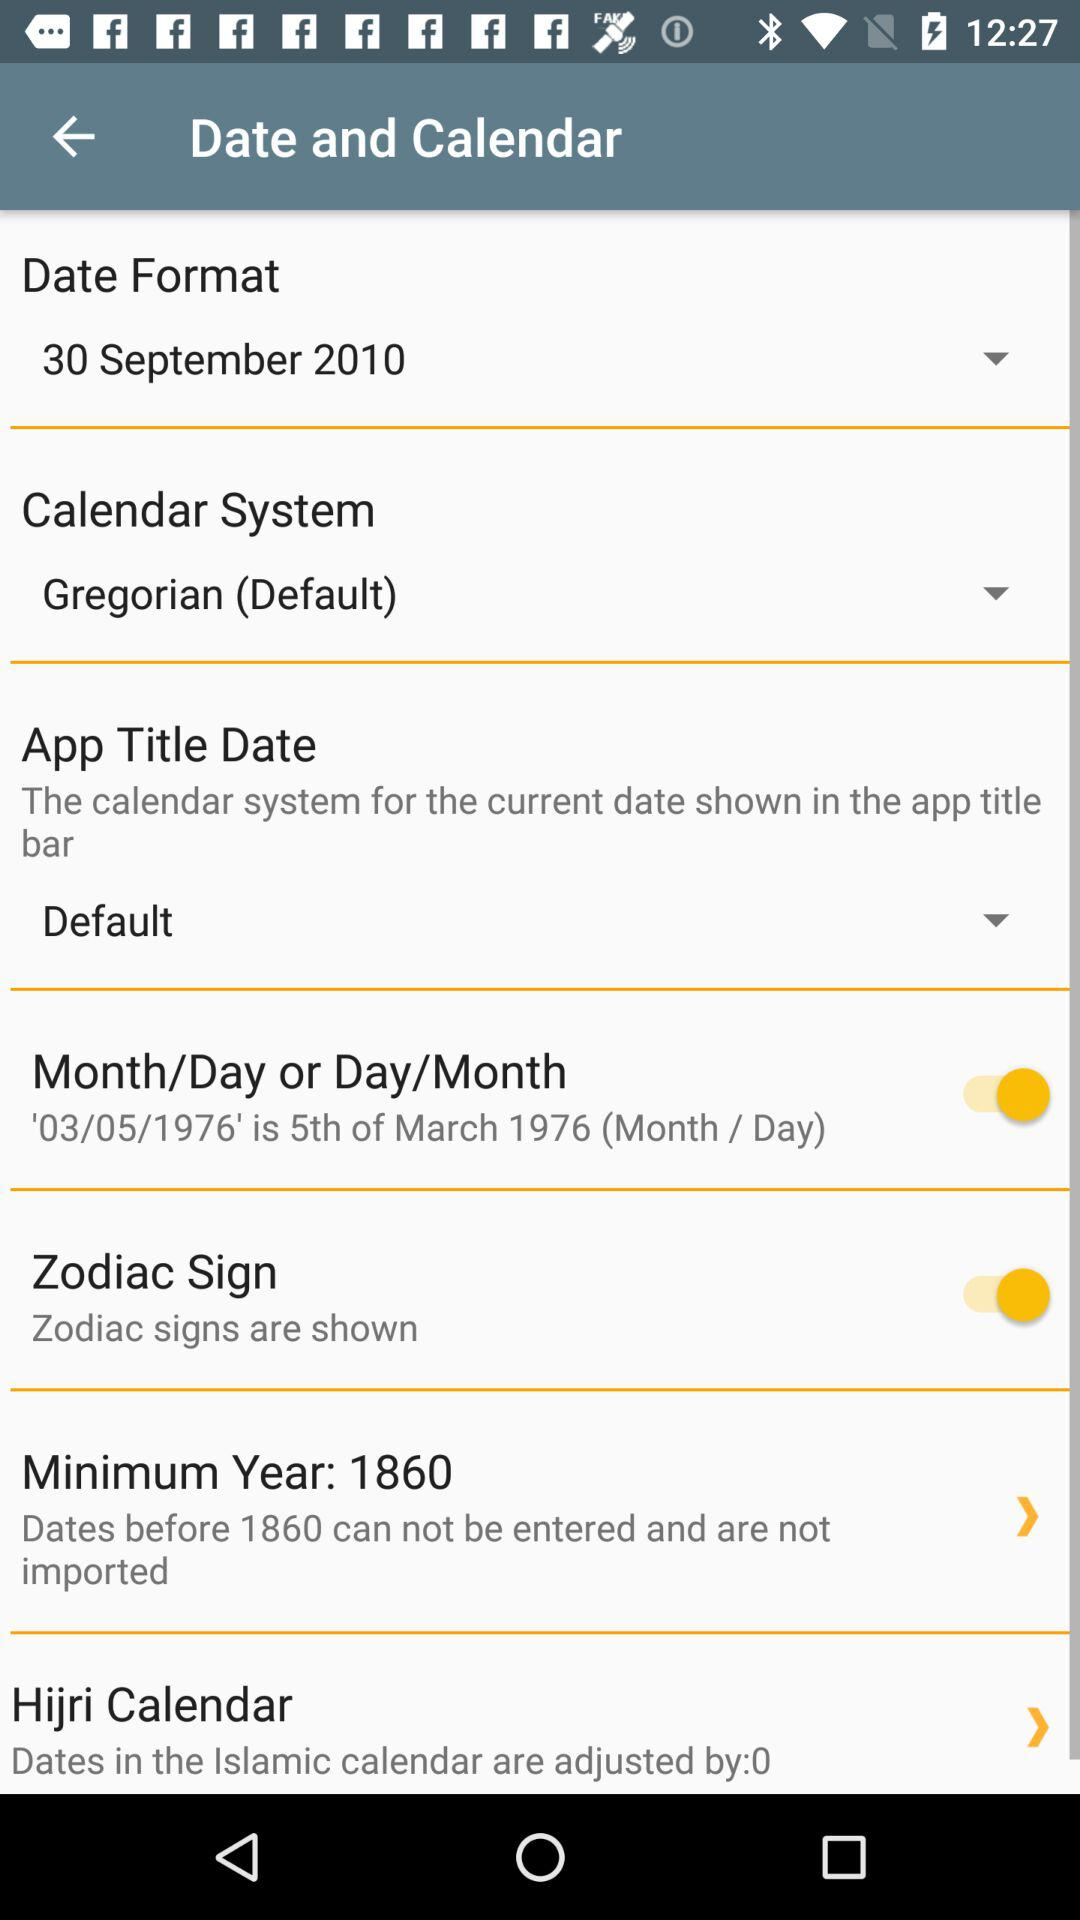What is the name of the application?
When the provided information is insufficient, respond with <no answer>. <no answer> 